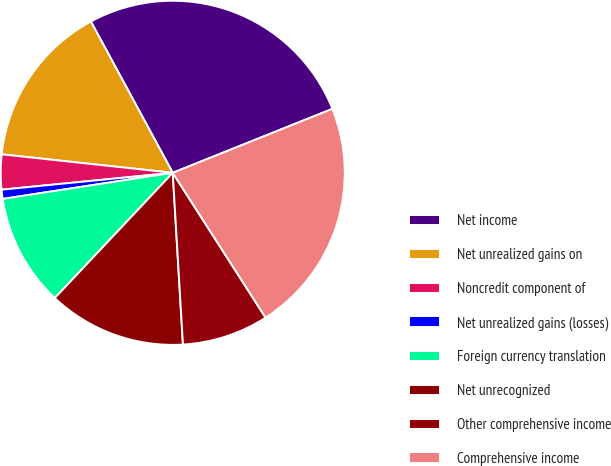Convert chart. <chart><loc_0><loc_0><loc_500><loc_500><pie_chart><fcel>Net income<fcel>Net unrealized gains on<fcel>Noncredit component of<fcel>Net unrealized gains (losses)<fcel>Foreign currency translation<fcel>Net unrecognized<fcel>Other comprehensive income<fcel>Comprehensive income<nl><fcel>26.83%<fcel>15.39%<fcel>3.28%<fcel>0.86%<fcel>10.55%<fcel>12.97%<fcel>8.13%<fcel>21.99%<nl></chart> 